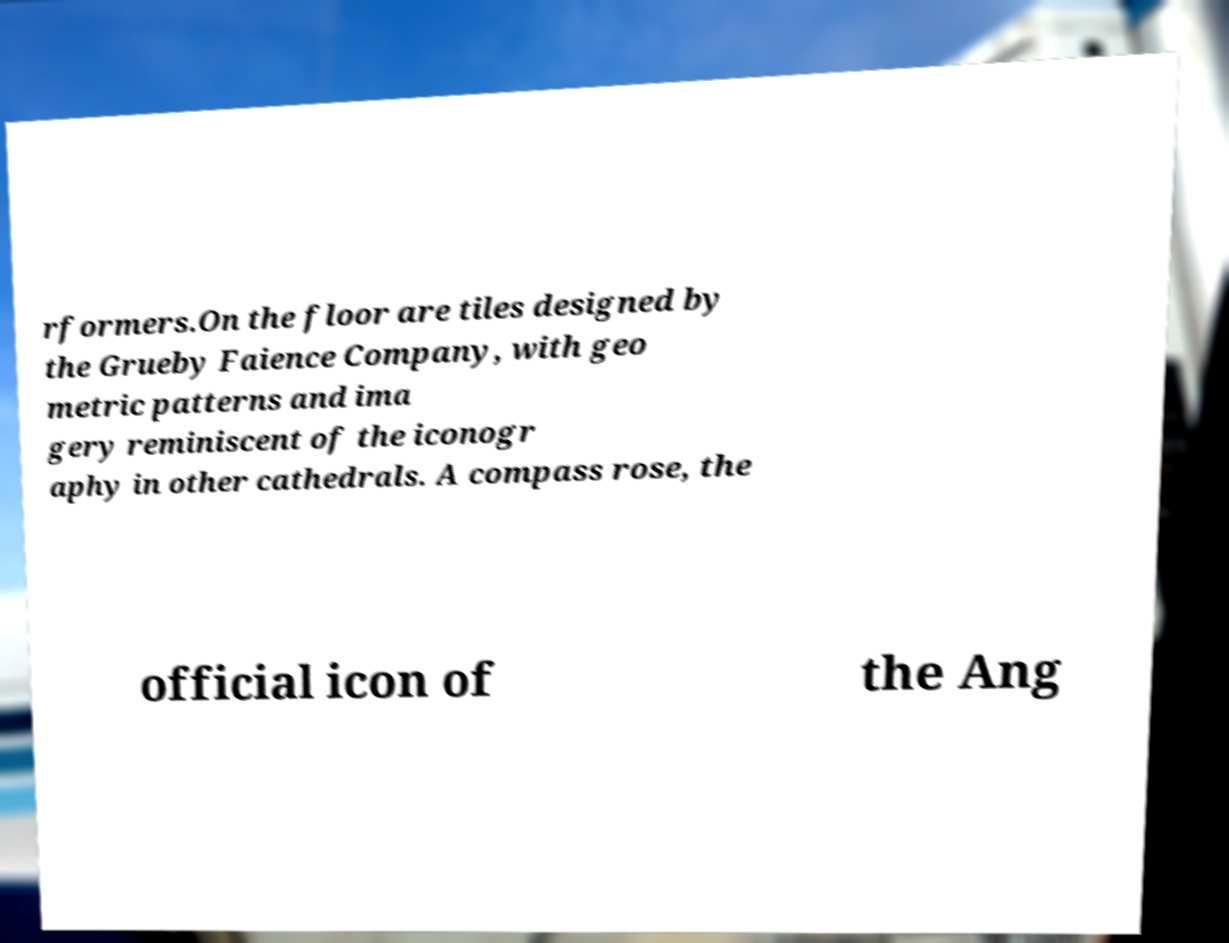Can you accurately transcribe the text from the provided image for me? rformers.On the floor are tiles designed by the Grueby Faience Company, with geo metric patterns and ima gery reminiscent of the iconogr aphy in other cathedrals. A compass rose, the official icon of the Ang 